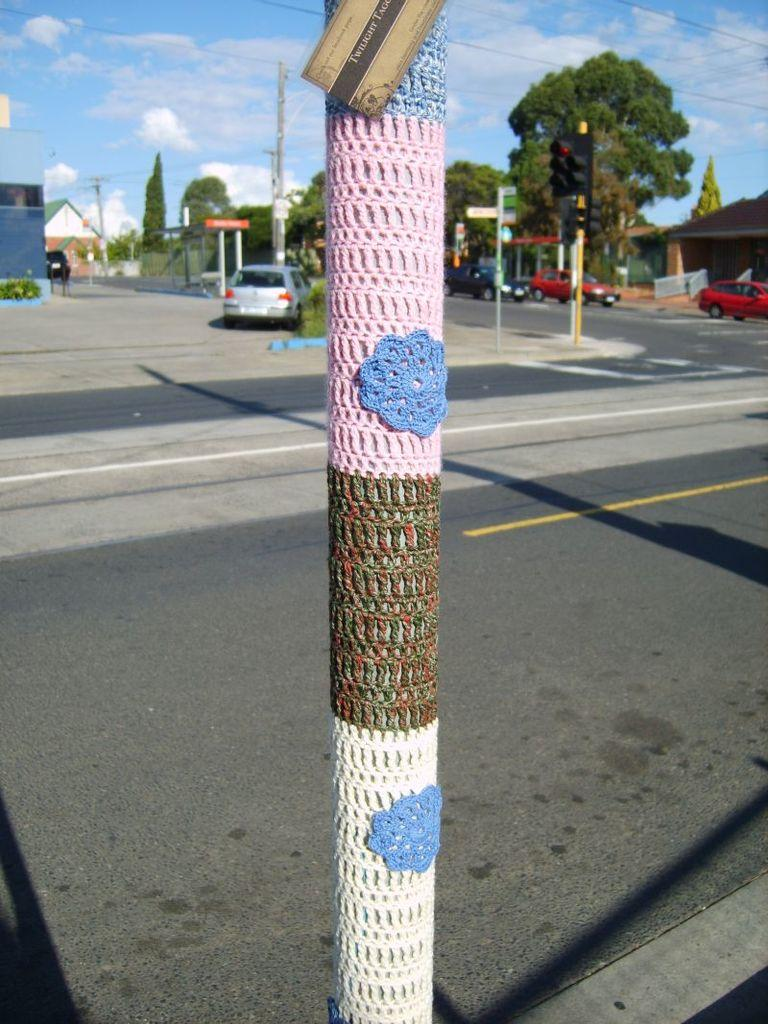What is the tall, vertical object in the image? There is a pole in the image. What type of structures can be seen in the image? There are buildings in the image. What type of vegetation is present in the image? There are trees in the image. What type of vehicles are visible in the image? There are cars in the image. What is visible at the top of the image? The sky is visible at the top of the image. What type of bone is used as a decorative element in the image? There is no bone present in the image. What type of lace can be seen on the buildings in the image? There is no lace present on the buildings in the image. 